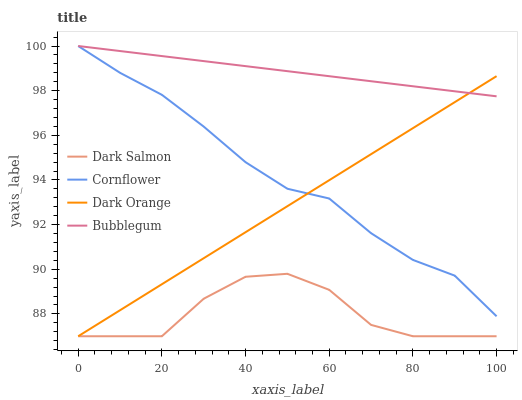Does Dark Salmon have the minimum area under the curve?
Answer yes or no. Yes. Does Bubblegum have the maximum area under the curve?
Answer yes or no. Yes. Does Bubblegum have the minimum area under the curve?
Answer yes or no. No. Does Dark Salmon have the maximum area under the curve?
Answer yes or no. No. Is Dark Orange the smoothest?
Answer yes or no. Yes. Is Dark Salmon the roughest?
Answer yes or no. Yes. Is Bubblegum the smoothest?
Answer yes or no. No. Is Bubblegum the roughest?
Answer yes or no. No. Does Dark Salmon have the lowest value?
Answer yes or no. Yes. Does Bubblegum have the lowest value?
Answer yes or no. No. Does Bubblegum have the highest value?
Answer yes or no. Yes. Does Dark Salmon have the highest value?
Answer yes or no. No. Is Dark Salmon less than Cornflower?
Answer yes or no. Yes. Is Cornflower greater than Dark Salmon?
Answer yes or no. Yes. Does Bubblegum intersect Dark Orange?
Answer yes or no. Yes. Is Bubblegum less than Dark Orange?
Answer yes or no. No. Is Bubblegum greater than Dark Orange?
Answer yes or no. No. Does Dark Salmon intersect Cornflower?
Answer yes or no. No. 